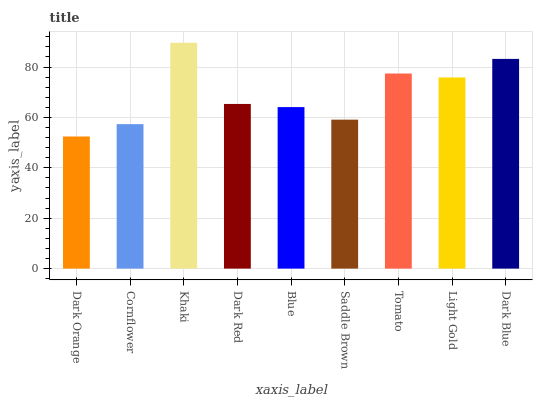Is Dark Orange the minimum?
Answer yes or no. Yes. Is Khaki the maximum?
Answer yes or no. Yes. Is Cornflower the minimum?
Answer yes or no. No. Is Cornflower the maximum?
Answer yes or no. No. Is Cornflower greater than Dark Orange?
Answer yes or no. Yes. Is Dark Orange less than Cornflower?
Answer yes or no. Yes. Is Dark Orange greater than Cornflower?
Answer yes or no. No. Is Cornflower less than Dark Orange?
Answer yes or no. No. Is Dark Red the high median?
Answer yes or no. Yes. Is Dark Red the low median?
Answer yes or no. Yes. Is Light Gold the high median?
Answer yes or no. No. Is Cornflower the low median?
Answer yes or no. No. 